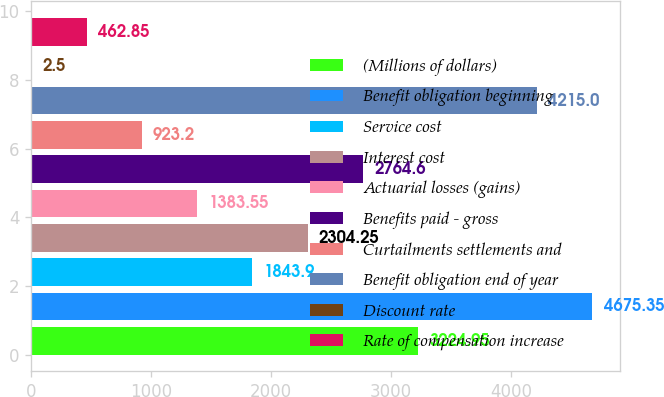Convert chart to OTSL. <chart><loc_0><loc_0><loc_500><loc_500><bar_chart><fcel>(Millions of dollars)<fcel>Benefit obligation beginning<fcel>Service cost<fcel>Interest cost<fcel>Actuarial losses (gains)<fcel>Benefits paid - gross<fcel>Curtailments settlements and<fcel>Benefit obligation end of year<fcel>Discount rate<fcel>Rate of compensation increase<nl><fcel>3224.95<fcel>4675.35<fcel>1843.9<fcel>2304.25<fcel>1383.55<fcel>2764.6<fcel>923.2<fcel>4215<fcel>2.5<fcel>462.85<nl></chart> 